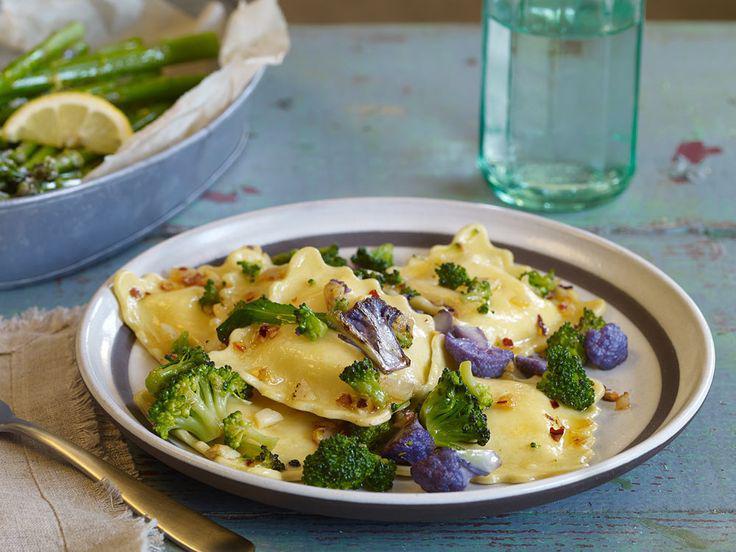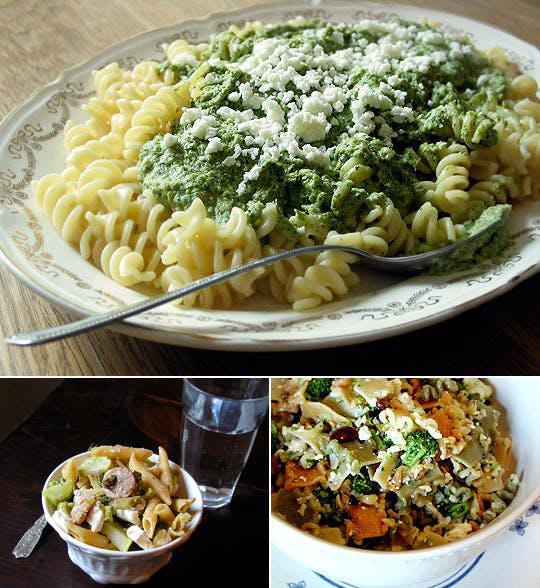The first image is the image on the left, the second image is the image on the right. For the images displayed, is the sentence "Left image shows food served in a rectangular dish." factually correct? Answer yes or no. No. The first image is the image on the left, the second image is the image on the right. Assess this claim about the two images: "At least one dish has pasta in it.". Correct or not? Answer yes or no. Yes. 